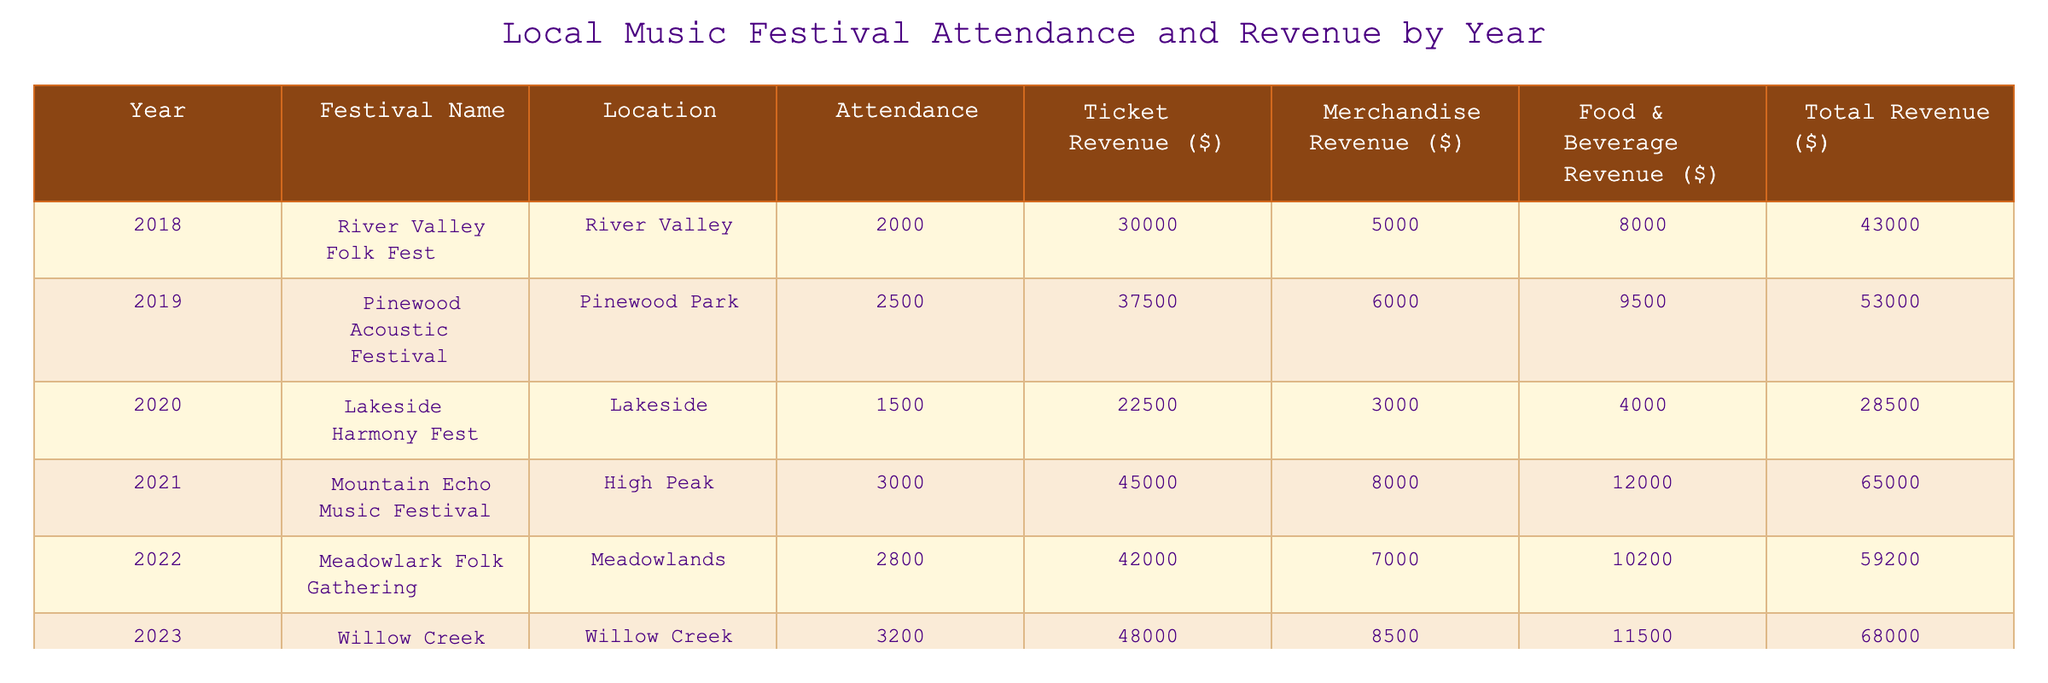What was the attendance at the Mountain Echo Music Festival? The table shows the attendance for the Mountain Echo Music Festival in 2021, which is listed as 3000.
Answer: 3000 What is the total revenue generated by the Willow Creek Heritage Festival? The total revenue for the Willow Creek Heritage Festival in 2023 is shown in the table as $68,000.
Answer: $68,000 Which festival had the highest merchandise revenue? By comparing the merchandise revenue values, the Mountain Echo Music Festival in 2021 had the highest at $8,000.
Answer: Mountain Echo Music Festival What is the total revenue generated from all festivals in 2022? The total revenue for the Meadowlark Folk Gathering in 2022 is $59,200; therefore, it’s the only figure to consider for that year.
Answer: $59,200 What year had the lowest attendance? The lowest attendance figure is from 2020, with a total of 1,500 attendees at the Lakeside Harmony Fest.
Answer: 2020 What was the average ticket revenue across all years? The ticket revenues are $30,000, $37,500, $22,500, $45,000, $42,000, and $48,000. Summing these gives $225,000. Dividing by 6 (the number of years), the average is $37,500.
Answer: $37,500 True or False: The total revenue in 2019 was greater than the total revenue in 2020. In the table, the total revenue for 2019 was $53,000 and for 2020 it was $28,500. Since $53,000 is greater than $28,500, the statement is true.
Answer: True Which festival saw the largest increase in attendance compared to the previous year? Comparing attendance year-over-year: 2020 had 1,500; 2021 had 3,000 (an increase of 1,500) and 2022 had 2,800 (an increase of 300). The largest increase is from 2020 to 2021.
Answer: 2021 What percentage of total revenue came from food and beverage sales at the River Valley Folk Fest? The total revenue for the River Valley Folk Fest is $43,000, and food and beverage revenue is $8,000. The percentage is calculated by ($8,000 / $43,000) * 100, which gives approximately 18.6%.
Answer: 18.6% What was the cumulative attendance for all festivals from 2018 to 2023? The cumulative attendance is calculated by summing the attendance for each year: 2000 + 2500 + 1500 + 3000 + 2800 + 3200 = 15000.
Answer: 15000 